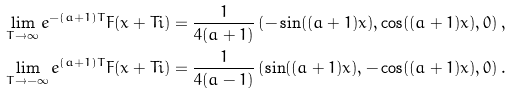<formula> <loc_0><loc_0><loc_500><loc_500>\lim _ { T \to \infty } e ^ { - ( a + 1 ) T } F ( x + T i ) & = \frac { 1 } { 4 ( a + 1 ) } \left ( - \sin ( ( a + 1 ) x ) , \cos ( ( a + 1 ) x ) , 0 \right ) , \\ \lim _ { T \to - \infty } e ^ { ( a + 1 ) T } F ( x + T i ) & = \frac { 1 } { 4 ( a - 1 ) } \left ( \sin ( ( a + 1 ) x ) , - \cos ( ( a + 1 ) x ) , 0 \right ) .</formula> 